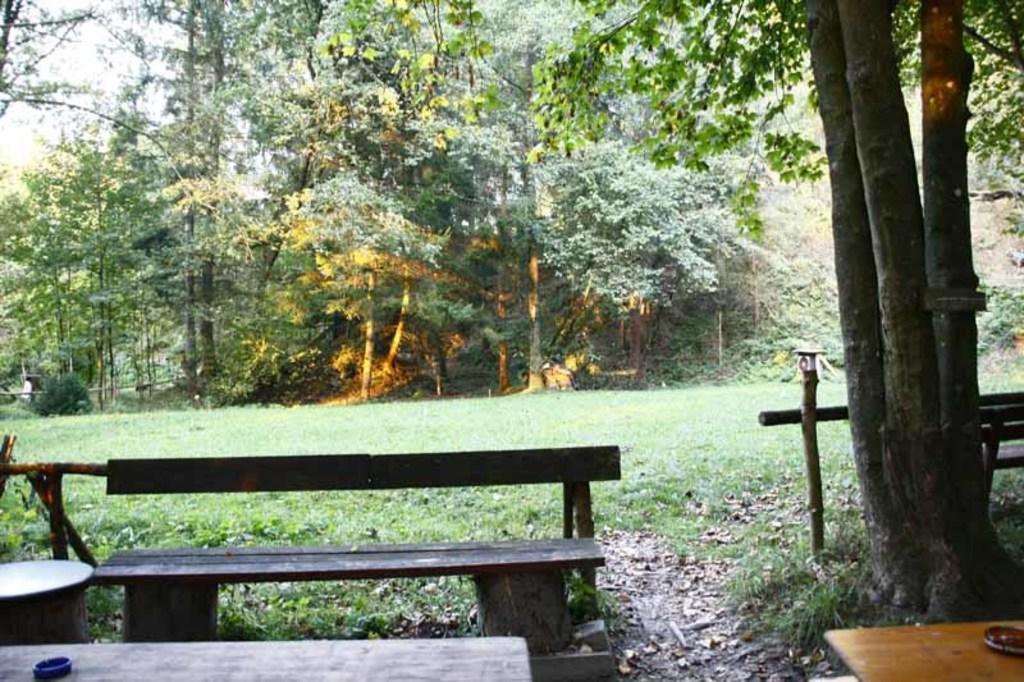Can you describe this image briefly? In this picture I can see the benches and tables. I can see trees. I can see green grass. 